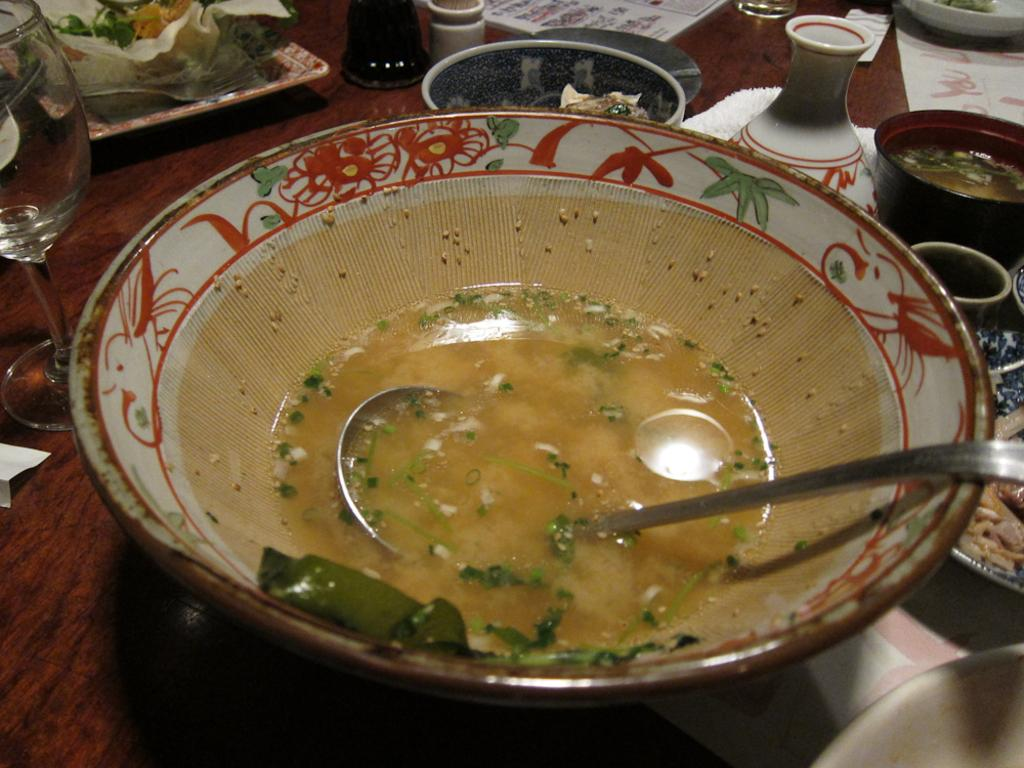What type of furniture is present in the image? There is a table in the image. What can be found on the table? There are many objects on the table, including glasses and a bowl with a food item in it. What utensil is visible in the image? There is a spoon in the image. What type of grape is being used as a decoration on the table in the image? There is no grape present in the image; it is not mentioned in the provided facts. 